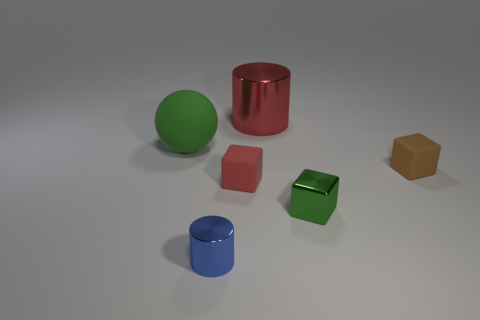Subtract all tiny matte blocks. How many blocks are left? 1 Add 1 small blue shiny objects. How many objects exist? 7 Subtract all spheres. How many objects are left? 5 Add 6 red cylinders. How many red cylinders exist? 7 Subtract 1 blue cylinders. How many objects are left? 5 Subtract all tiny green things. Subtract all metal blocks. How many objects are left? 4 Add 3 tiny green objects. How many tiny green objects are left? 4 